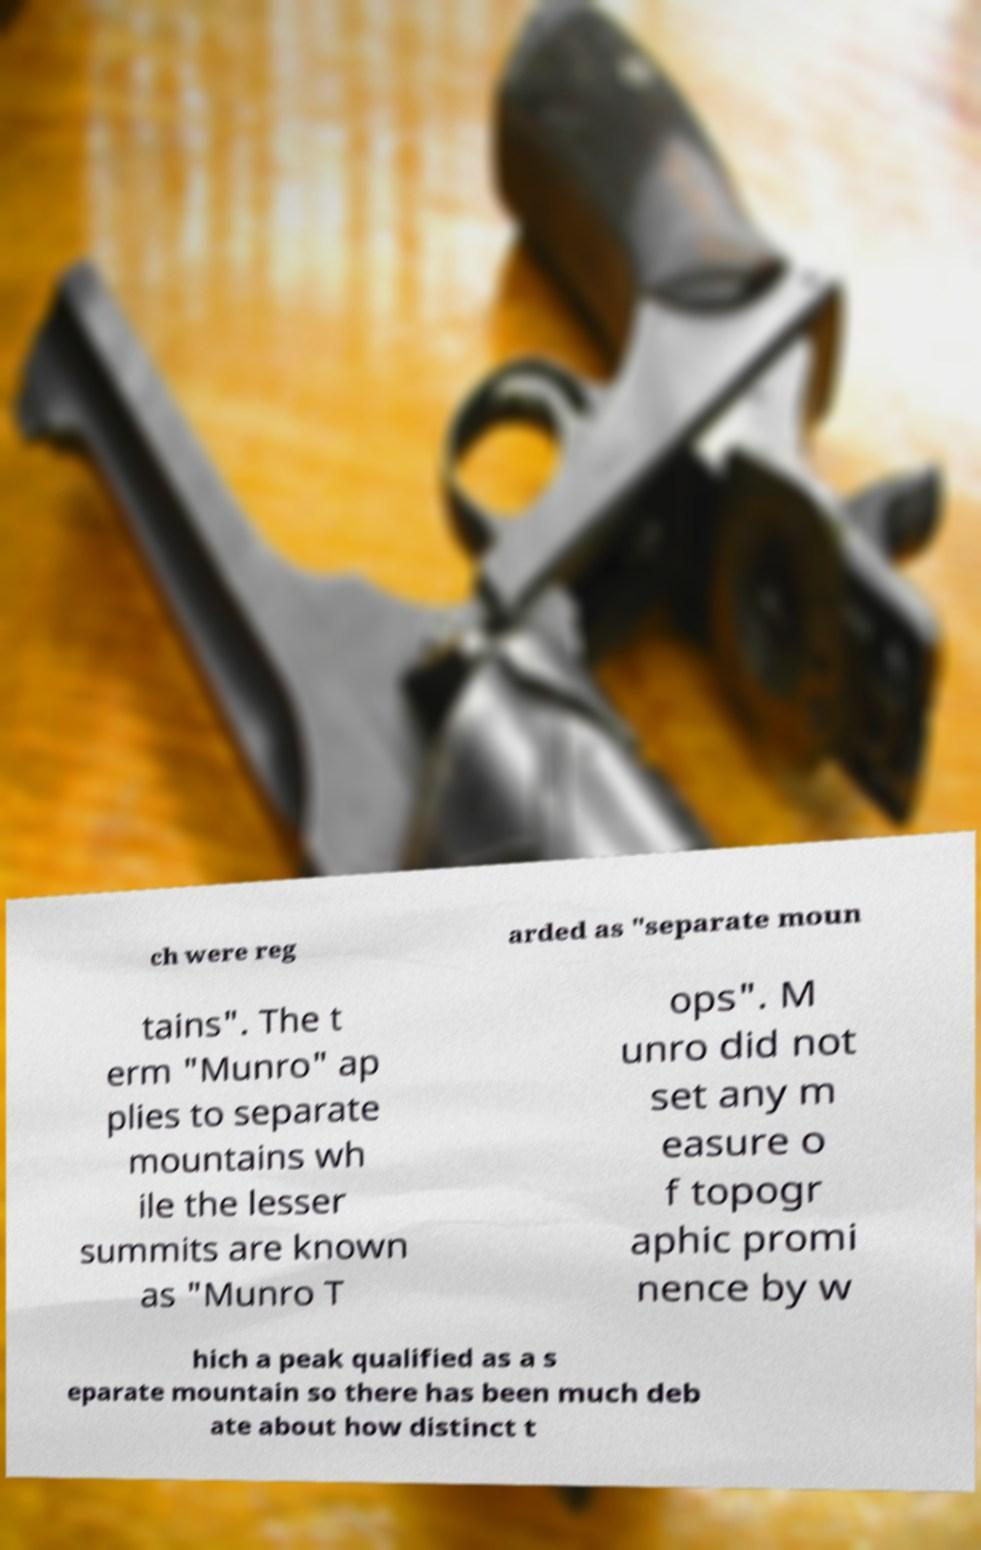There's text embedded in this image that I need extracted. Can you transcribe it verbatim? ch were reg arded as "separate moun tains". The t erm "Munro" ap plies to separate mountains wh ile the lesser summits are known as "Munro T ops". M unro did not set any m easure o f topogr aphic promi nence by w hich a peak qualified as a s eparate mountain so there has been much deb ate about how distinct t 